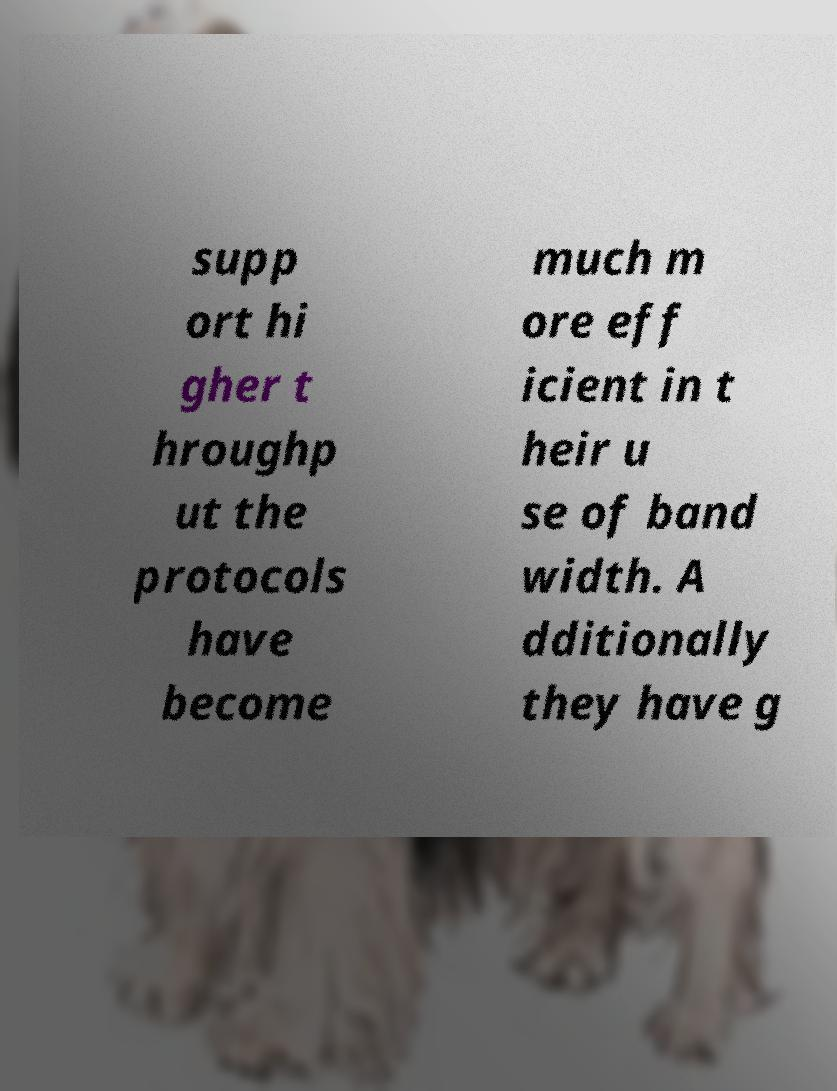For documentation purposes, I need the text within this image transcribed. Could you provide that? supp ort hi gher t hroughp ut the protocols have become much m ore eff icient in t heir u se of band width. A dditionally they have g 